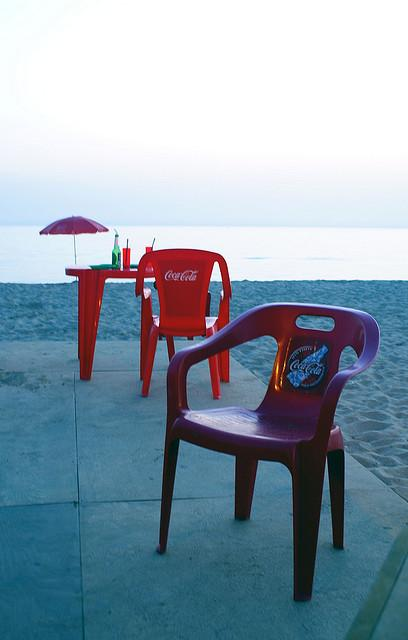What drink brand is seen on the chairs? Please explain your reasoning. coca cola. It is red and white with the logo 